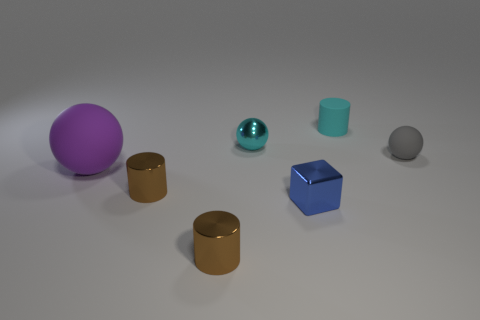How many cylinders are big objects or tiny gray objects?
Offer a terse response. 0. There is a shiny object that is behind the matte object to the left of the small cyan metallic object that is behind the tiny blue metallic cube; what size is it?
Provide a succinct answer. Small. The other gray rubber object that is the same shape as the large thing is what size?
Ensure brevity in your answer.  Small. There is a blue metal cube; what number of tiny cylinders are to the left of it?
Ensure brevity in your answer.  2. Do the matte ball that is to the right of the large purple rubber sphere and the shiny block have the same color?
Offer a terse response. No. How many cyan things are either small rubber cylinders or rubber things?
Offer a very short reply. 1. There is a shiny object behind the brown metal object that is behind the small blue metal cube; what color is it?
Ensure brevity in your answer.  Cyan. There is a small cylinder that is the same color as the tiny metallic ball; what is its material?
Offer a very short reply. Rubber. There is a shiny thing in front of the tiny blue shiny block; what color is it?
Your answer should be very brief. Brown. There is a blue metal block that is in front of the cyan rubber object; is it the same size as the cyan metal thing?
Your answer should be compact. Yes. 